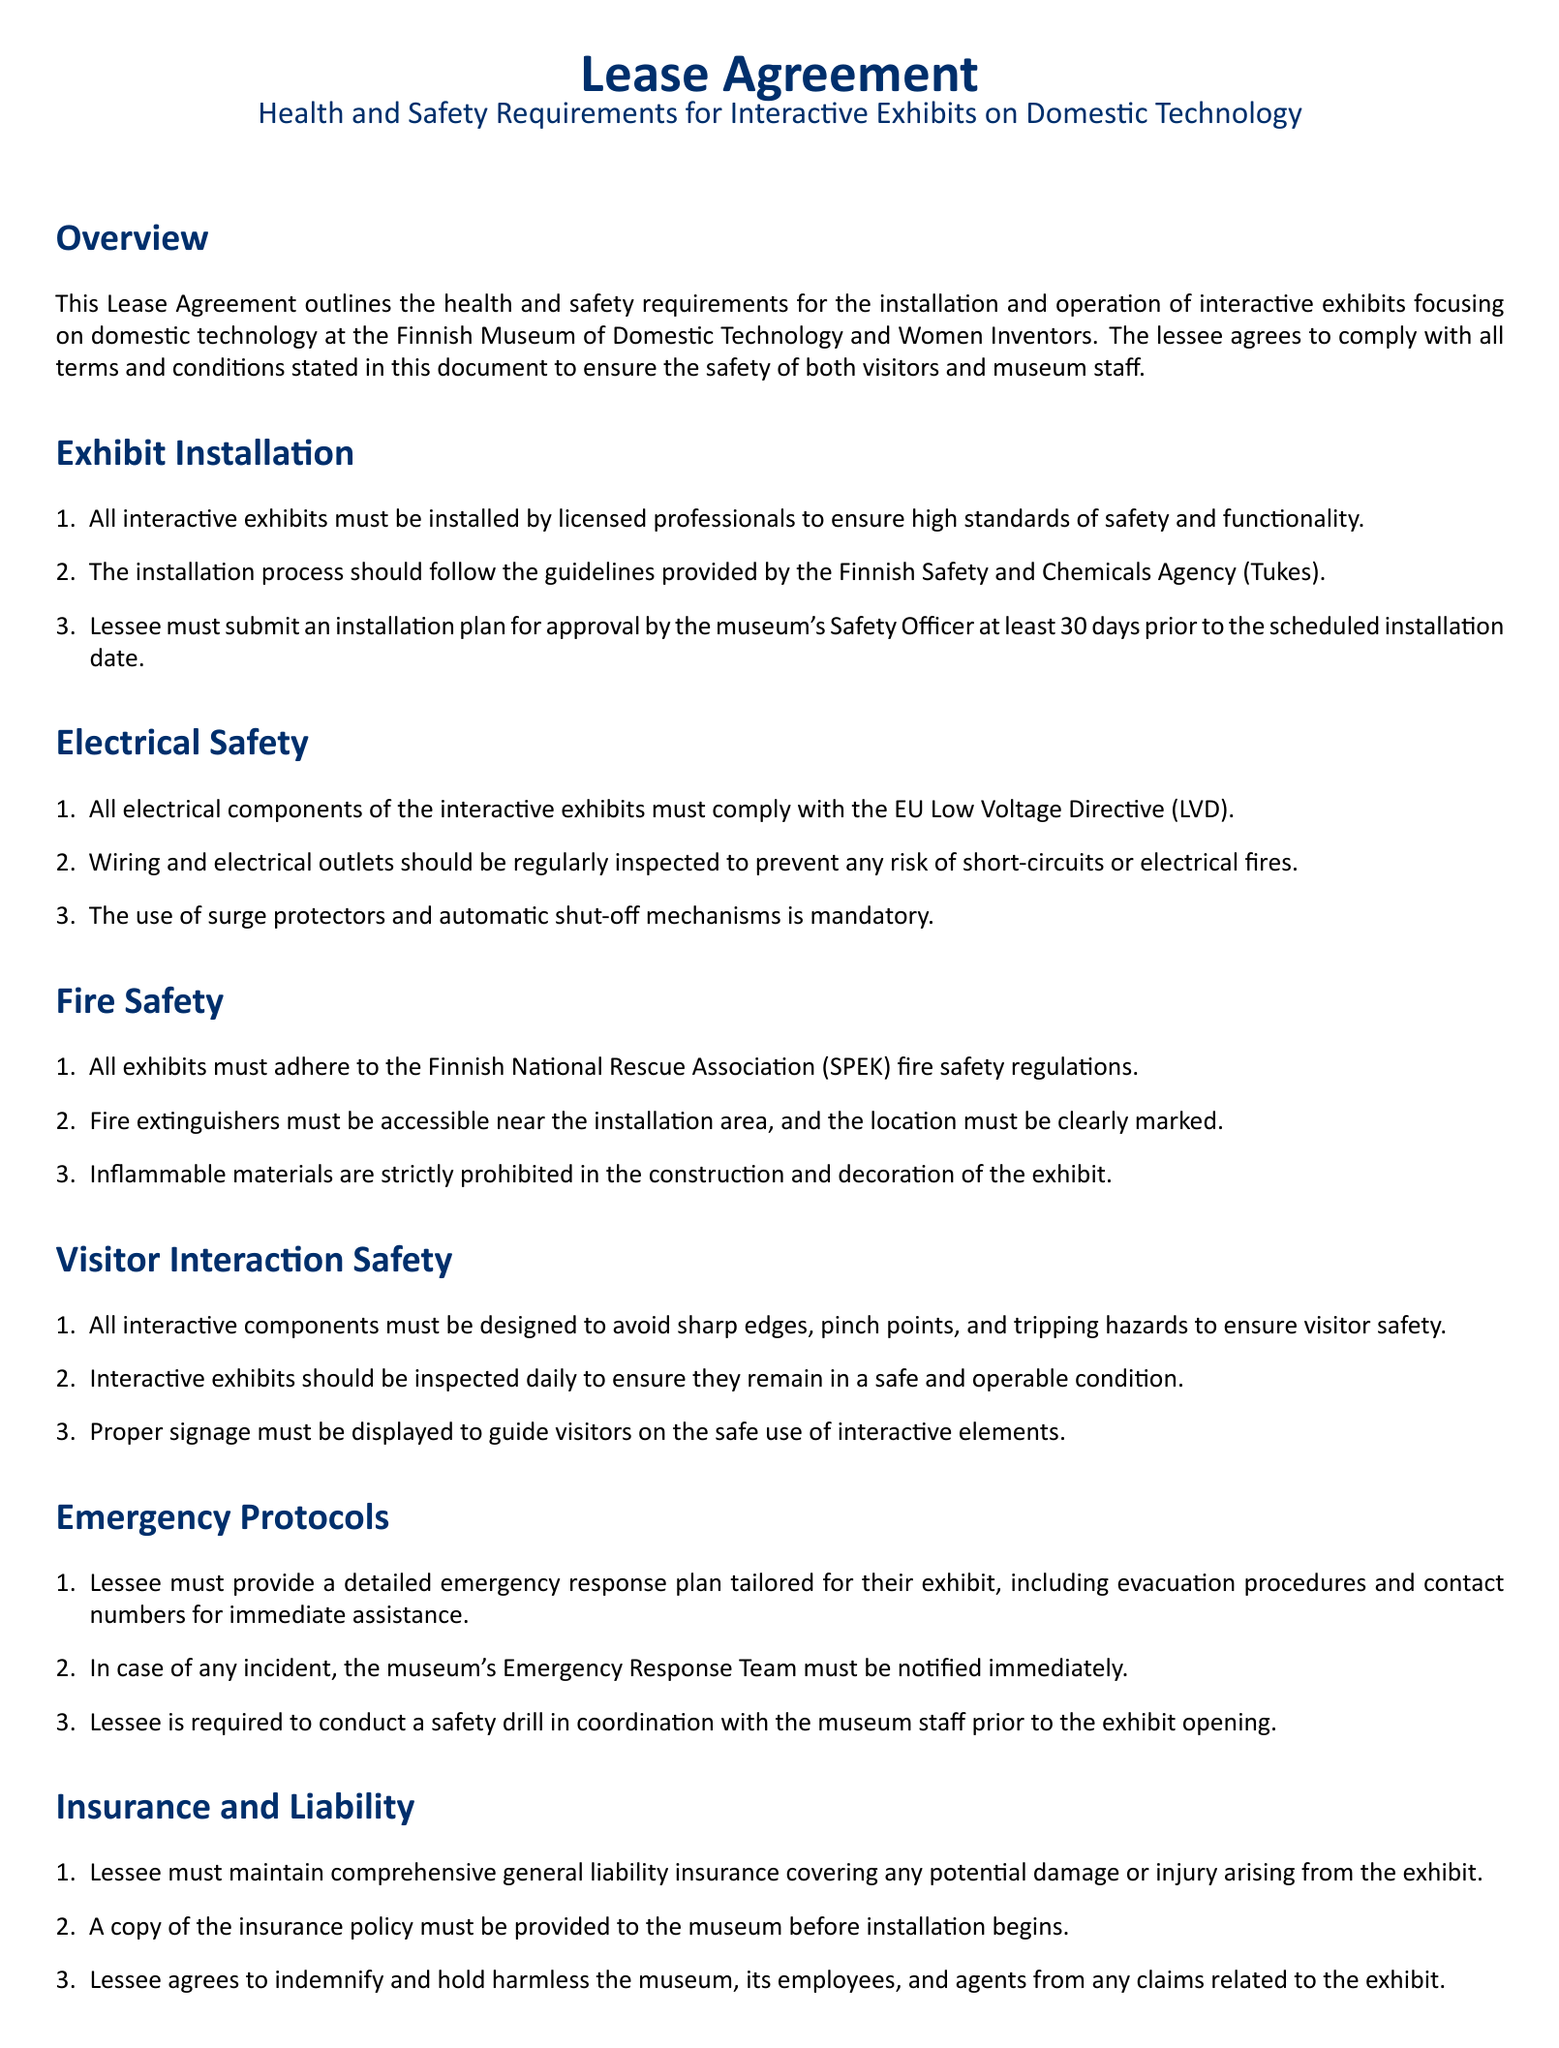What is the main focus of the Lease Agreement? The Lease Agreement outlines health and safety requirements for interactive exhibits focusing on domestic technology at the museum.
Answer: domestic technology Who must approve the installation plan? The installation plan must be approved by the museum's Safety Officer.
Answer: Safety Officer What is the EU directive that electrical components must comply with? The electrical components must comply with the EU Low Voltage Directive (LVD).
Answer: Low Voltage Directive (LVD) How often should interactive exhibits be inspected? Interactive exhibits should be inspected daily to ensure they remain safe and operable.
Answer: daily Is comprehensive general liability insurance required? Yes, the lessee must maintain comprehensive general liability insurance covering potential damage or injury from the exhibit.
Answer: Yes What should be clearly marked near the installation area? Fire extinguishers must be accessible and their location must be clearly marked.
Answer: Fire extinguishers What must the lessee provide before installation begins? The lessee must provide a copy of the insurance policy to the museum before installation.
Answer: insurance policy What type of materials are prohibited in the construction and decoration of the exhibit? Inflammable materials are strictly prohibited.
Answer: Inflammable materials What must the lessee maintain records of? The lessee is required to maintain records of all safety inspections, repairs, and maintenance activities.
Answer: safety inspections, repairs, and maintenance activities 